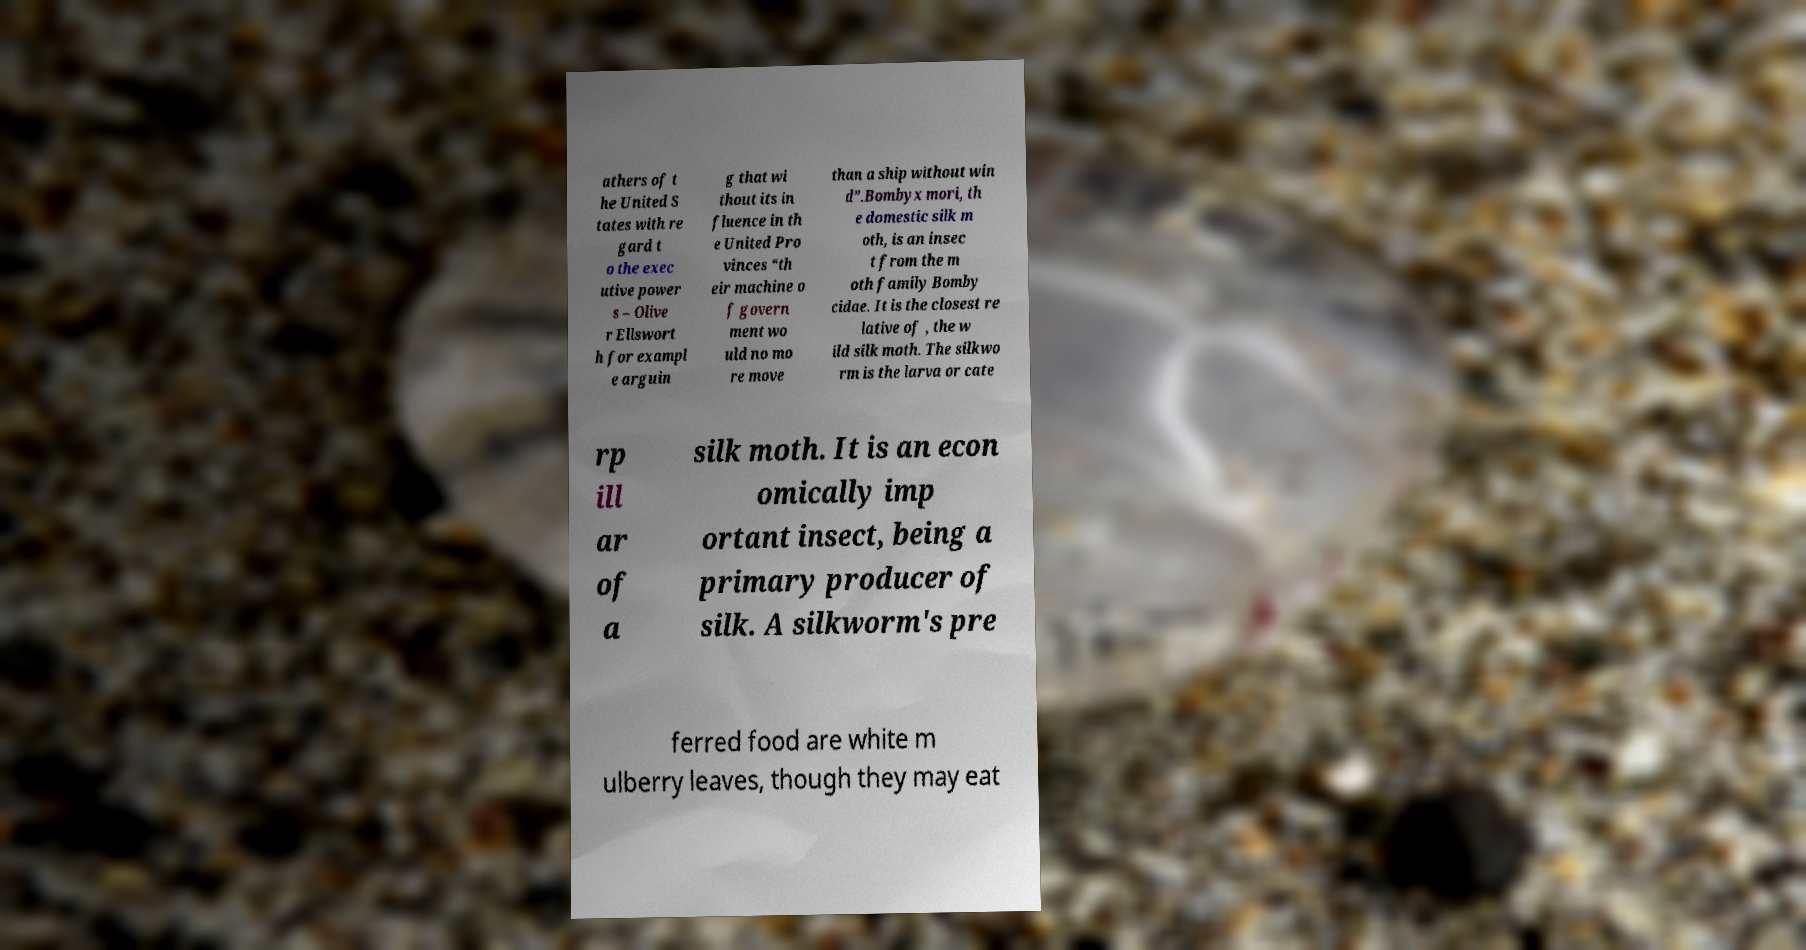There's text embedded in this image that I need extracted. Can you transcribe it verbatim? athers of t he United S tates with re gard t o the exec utive power s – Olive r Ellswort h for exampl e arguin g that wi thout its in fluence in th e United Pro vinces “th eir machine o f govern ment wo uld no mo re move than a ship without win d”.Bombyx mori, th e domestic silk m oth, is an insec t from the m oth family Bomby cidae. It is the closest re lative of , the w ild silk moth. The silkwo rm is the larva or cate rp ill ar of a silk moth. It is an econ omically imp ortant insect, being a primary producer of silk. A silkworm's pre ferred food are white m ulberry leaves, though they may eat 